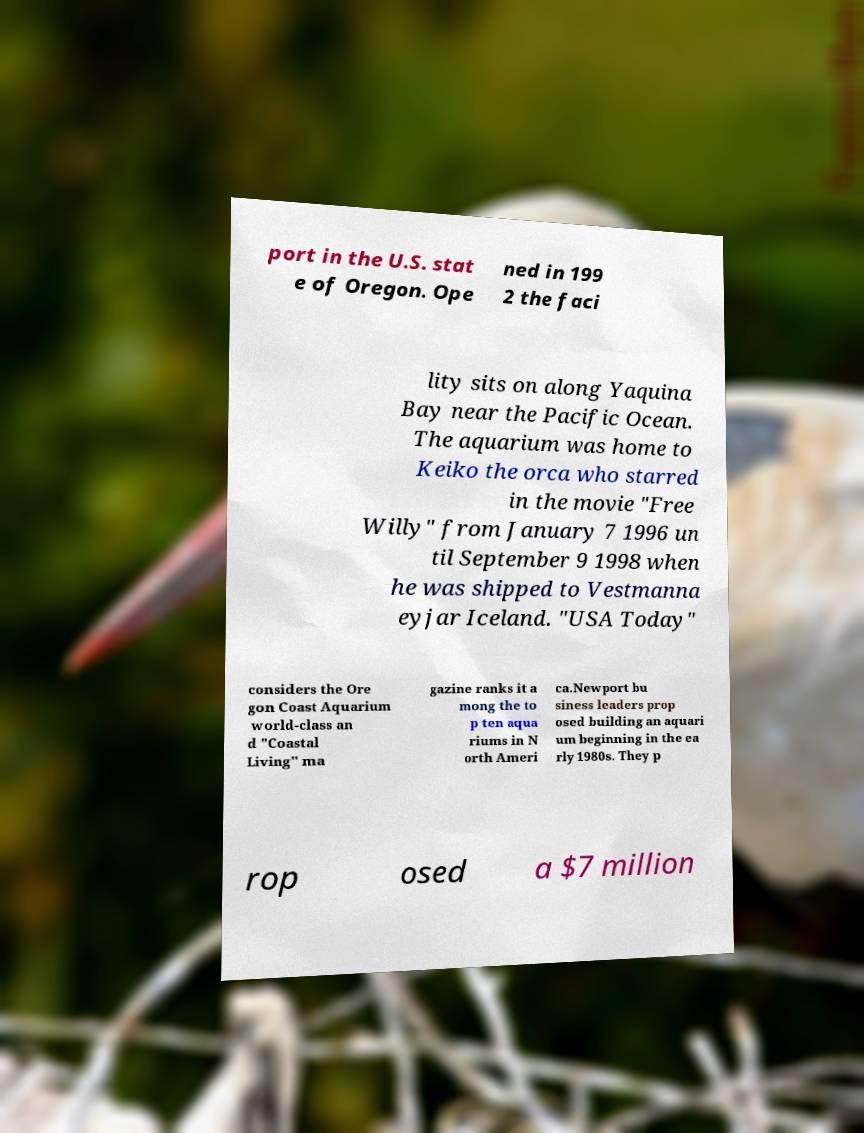Please read and relay the text visible in this image. What does it say? port in the U.S. stat e of Oregon. Ope ned in 199 2 the faci lity sits on along Yaquina Bay near the Pacific Ocean. The aquarium was home to Keiko the orca who starred in the movie "Free Willy" from January 7 1996 un til September 9 1998 when he was shipped to Vestmanna eyjar Iceland. "USA Today" considers the Ore gon Coast Aquarium world-class an d "Coastal Living" ma gazine ranks it a mong the to p ten aqua riums in N orth Ameri ca.Newport bu siness leaders prop osed building an aquari um beginning in the ea rly 1980s. They p rop osed a $7 million 